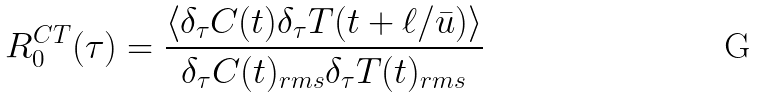<formula> <loc_0><loc_0><loc_500><loc_500>R _ { 0 } ^ { C T } ( \tau ) = \frac { \langle \delta _ { \tau } C ( t ) \delta _ { \tau } T ( t + \ell / \bar { u } ) \rangle } { \delta _ { \tau } C ( t ) _ { r m s } \delta _ { \tau } T ( t ) _ { r m s } }</formula> 